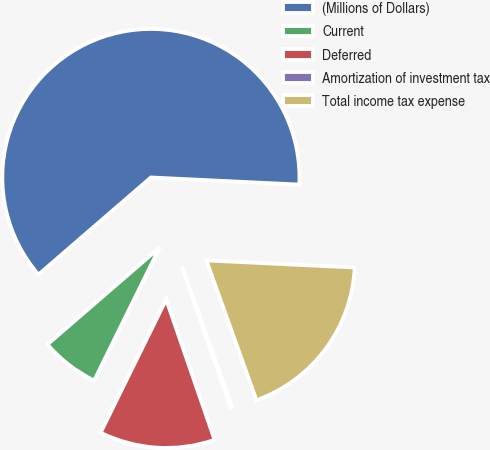<chart> <loc_0><loc_0><loc_500><loc_500><pie_chart><fcel>(Millions of Dollars)<fcel>Current<fcel>Deferred<fcel>Amortization of investment tax<fcel>Total income tax expense<nl><fcel>62.11%<fcel>6.38%<fcel>12.57%<fcel>0.19%<fcel>18.76%<nl></chart> 